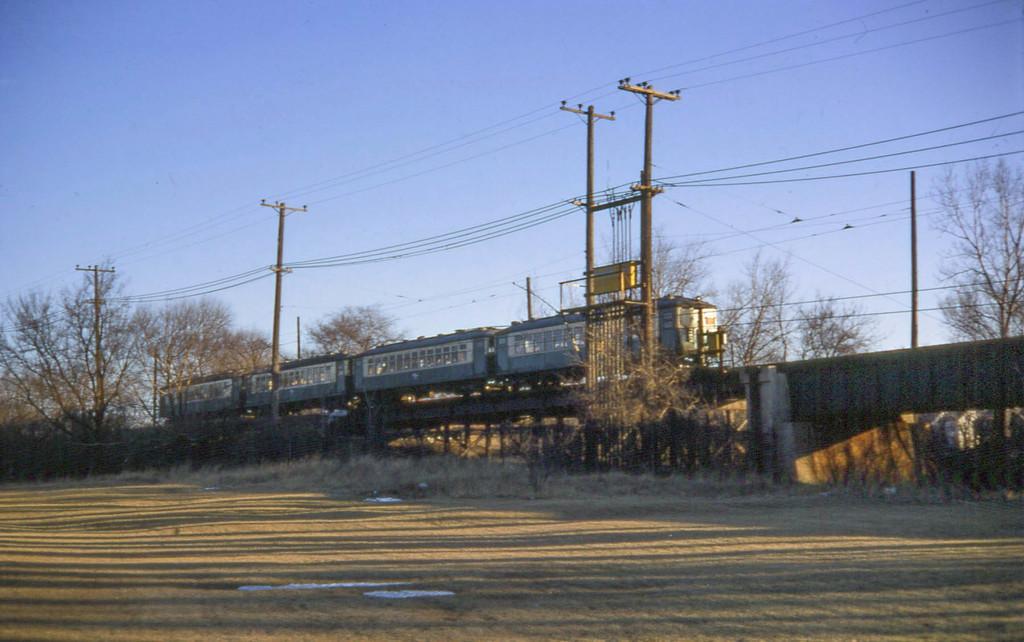Please provide a concise description of this image. In this image there is a train on the bridge. There are electrical poles with cables. There are trees, poles. At the bottom of the image there is grass on the surface. In the background of the image there is sky. 